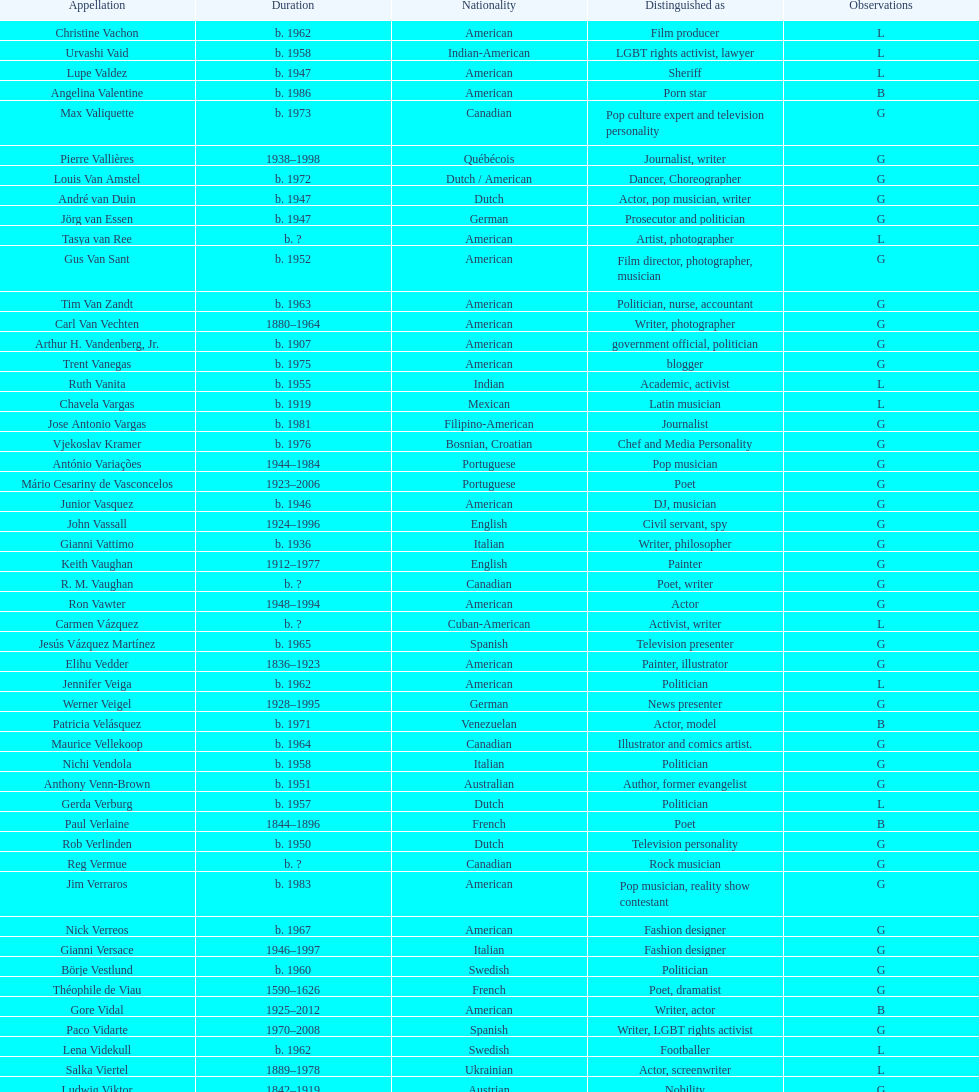At what age did pierre vallieres die? 60. 